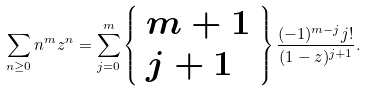<formula> <loc_0><loc_0><loc_500><loc_500>\sum _ { n \geq 0 } n ^ { m } z ^ { n } = \sum _ { j = 0 } ^ { m } \left \{ { \begin{array} { l } { m + 1 } \\ { j + 1 } \end{array} } \right \} { \frac { ( - 1 ) ^ { m - j } j ! } { ( 1 - z ) ^ { j + 1 } } } .</formula> 